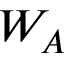Convert formula to latex. <formula><loc_0><loc_0><loc_500><loc_500>W _ { A }</formula> 